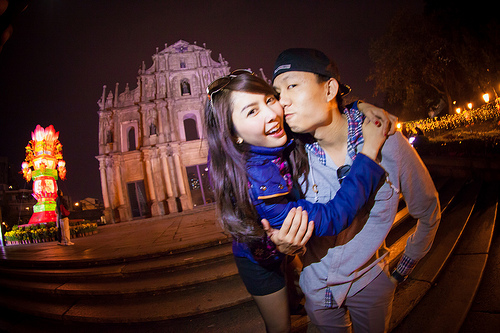<image>
Is there a person under the hat? No. The person is not positioned under the hat. The vertical relationship between these objects is different. 